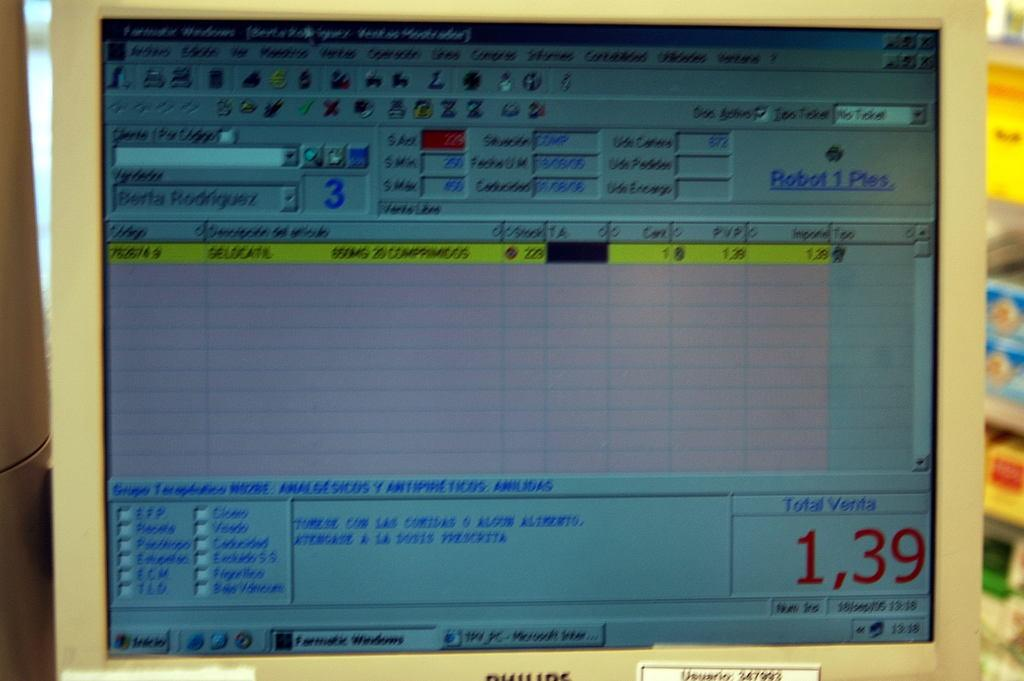Provide a one-sentence caption for the provided image. Computer screen that shots the Total Venta at 1,39. 